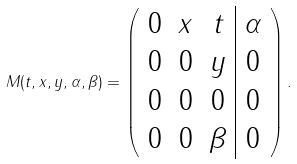<formula> <loc_0><loc_0><loc_500><loc_500>M ( t , x , y , \alpha , \beta ) = \left ( \begin{array} { c c c | c } 0 & x & t & \alpha \\ 0 & 0 & y & 0 \\ 0 & 0 & 0 & 0 \\ 0 & 0 & \beta & 0 \end{array} \right ) .</formula> 